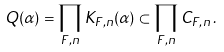<formula> <loc_0><loc_0><loc_500><loc_500>Q ( \alpha ) = \prod _ { F , n } K _ { F , n } ( \alpha ) \subset \prod _ { F , n } C _ { F , n } \, .</formula> 